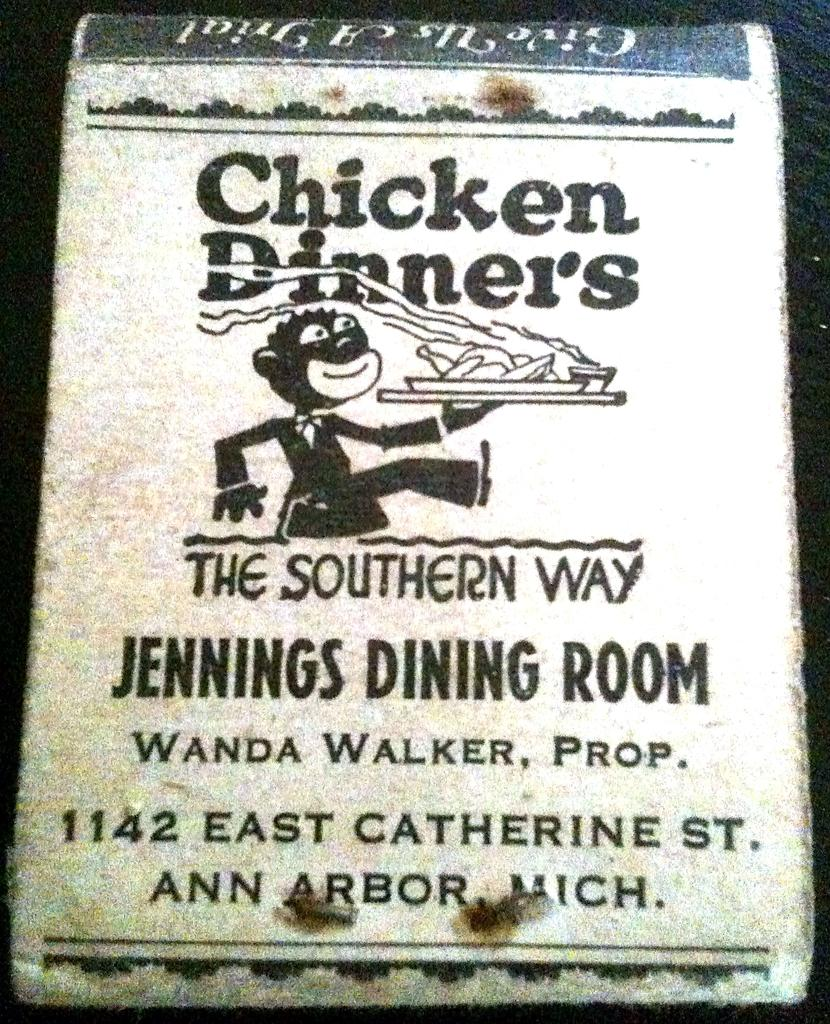<image>
Render a clear and concise summary of the photo. A sign for a restaurant called Jennings Dining Room, chicken dinners the Southern way. 